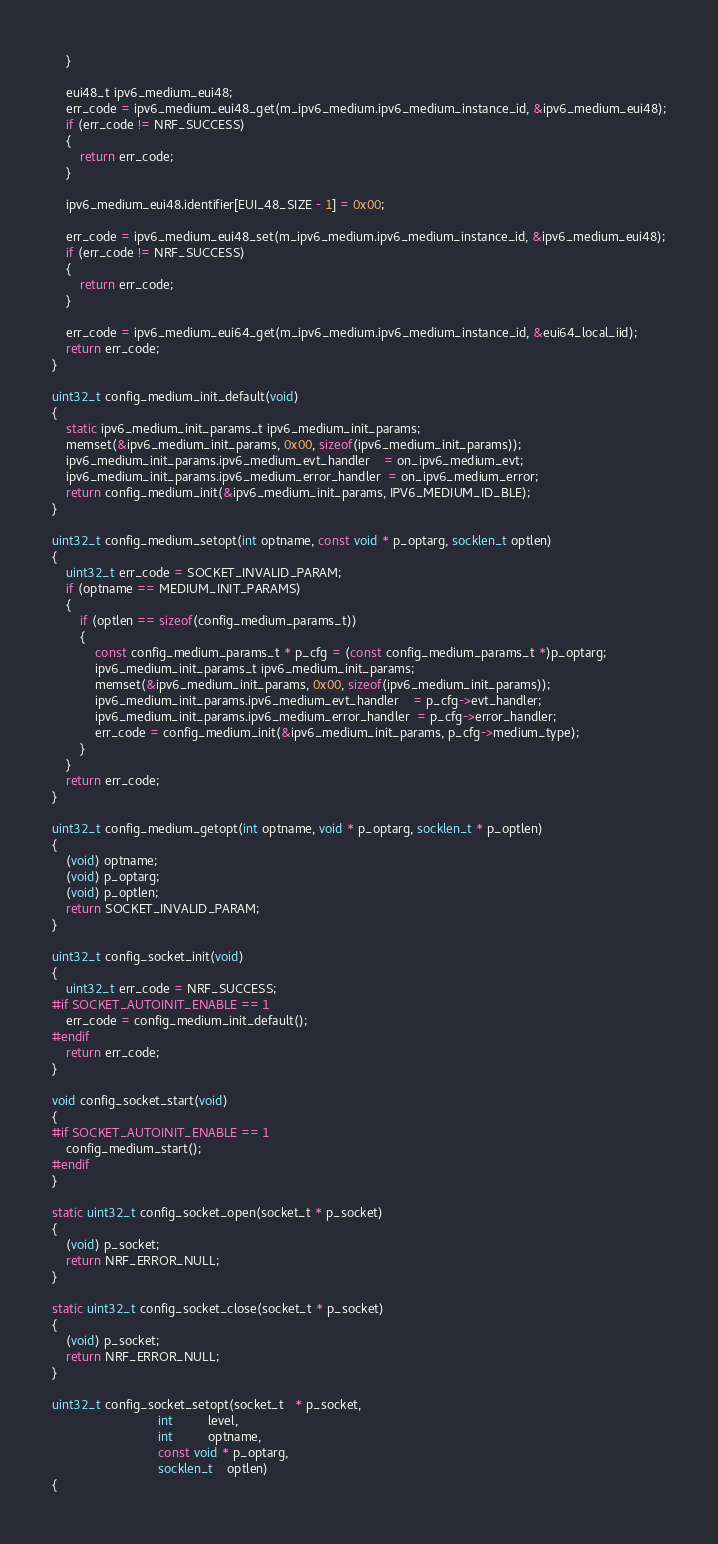Convert code to text. <code><loc_0><loc_0><loc_500><loc_500><_C_>    }

    eui48_t ipv6_medium_eui48;
    err_code = ipv6_medium_eui48_get(m_ipv6_medium.ipv6_medium_instance_id, &ipv6_medium_eui48);
    if (err_code != NRF_SUCCESS)
    {
        return err_code;
    }

    ipv6_medium_eui48.identifier[EUI_48_SIZE - 1] = 0x00;

    err_code = ipv6_medium_eui48_set(m_ipv6_medium.ipv6_medium_instance_id, &ipv6_medium_eui48);
    if (err_code != NRF_SUCCESS)
    {
        return err_code;
    }

    err_code = ipv6_medium_eui64_get(m_ipv6_medium.ipv6_medium_instance_id, &eui64_local_iid);
    return err_code;
}

uint32_t config_medium_init_default(void)
{
    static ipv6_medium_init_params_t ipv6_medium_init_params;
    memset(&ipv6_medium_init_params, 0x00, sizeof(ipv6_medium_init_params));
    ipv6_medium_init_params.ipv6_medium_evt_handler    = on_ipv6_medium_evt;
    ipv6_medium_init_params.ipv6_medium_error_handler  = on_ipv6_medium_error;
    return config_medium_init(&ipv6_medium_init_params, IPV6_MEDIUM_ID_BLE);
}

uint32_t config_medium_setopt(int optname, const void * p_optarg, socklen_t optlen)
{
    uint32_t err_code = SOCKET_INVALID_PARAM;
    if (optname == MEDIUM_INIT_PARAMS)
    {
        if (optlen == sizeof(config_medium_params_t))
        {
            const config_medium_params_t * p_cfg = (const config_medium_params_t *)p_optarg;
            ipv6_medium_init_params_t ipv6_medium_init_params;
            memset(&ipv6_medium_init_params, 0x00, sizeof(ipv6_medium_init_params));
            ipv6_medium_init_params.ipv6_medium_evt_handler    = p_cfg->evt_handler;
            ipv6_medium_init_params.ipv6_medium_error_handler  = p_cfg->error_handler;
            err_code = config_medium_init(&ipv6_medium_init_params, p_cfg->medium_type);
        }
    }
    return err_code;
}

uint32_t config_medium_getopt(int optname, void * p_optarg, socklen_t * p_optlen)
{
    (void) optname;
    (void) p_optarg;
    (void) p_optlen;
    return SOCKET_INVALID_PARAM;
}

uint32_t config_socket_init(void)
{
    uint32_t err_code = NRF_SUCCESS;
#if SOCKET_AUTOINIT_ENABLE == 1
    err_code = config_medium_init_default();
#endif
    return err_code;
}

void config_socket_start(void)
{
#if SOCKET_AUTOINIT_ENABLE == 1
    config_medium_start();
#endif
}

static uint32_t config_socket_open(socket_t * p_socket)
{
    (void) p_socket;
    return NRF_ERROR_NULL;
}

static uint32_t config_socket_close(socket_t * p_socket)
{
    (void) p_socket;
    return NRF_ERROR_NULL;
}

uint32_t config_socket_setopt(socket_t   * p_socket,
                              int          level,
                              int          optname,
                              const void * p_optarg,
                              socklen_t    optlen)
{</code> 